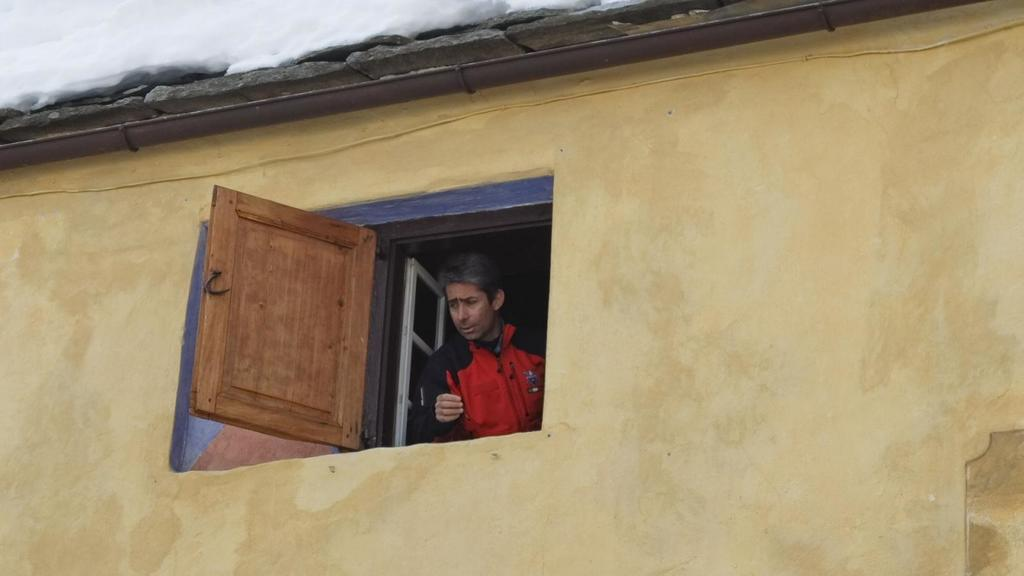What is the main subject of the image? The main subject of the image is a building. Can you describe the person in the image? There is a person standing inside the building behind a window. What type of material covers the top of the building? There are roof tiles at the top of the building. What is attached to the wall of the building? There is a wire on the wall of the building. What type of farm animals can be seen grazing in the image? There are no farm animals present in the image; it is a picture of a building with a person, roof tiles, and a wire on the wall. 